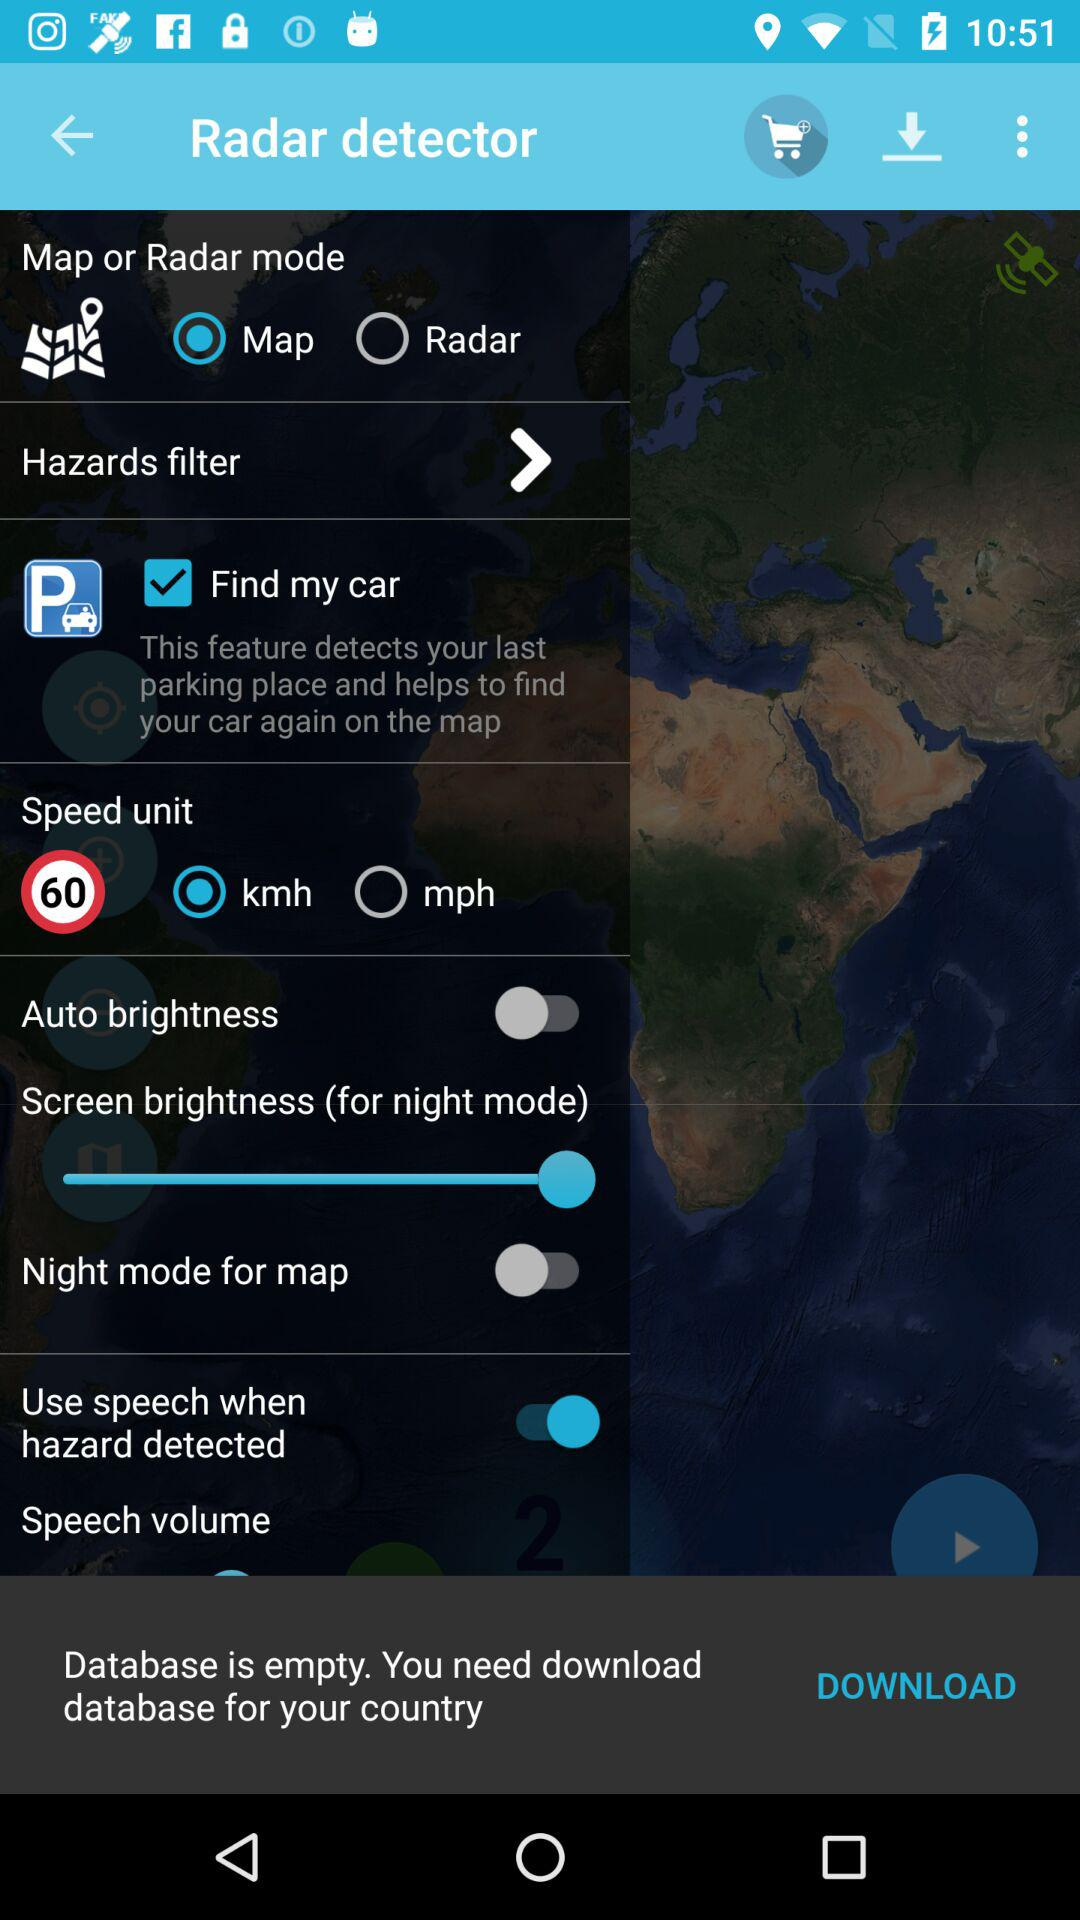What is the radar mode?
When the provided information is insufficient, respond with <no answer>. <no answer> 